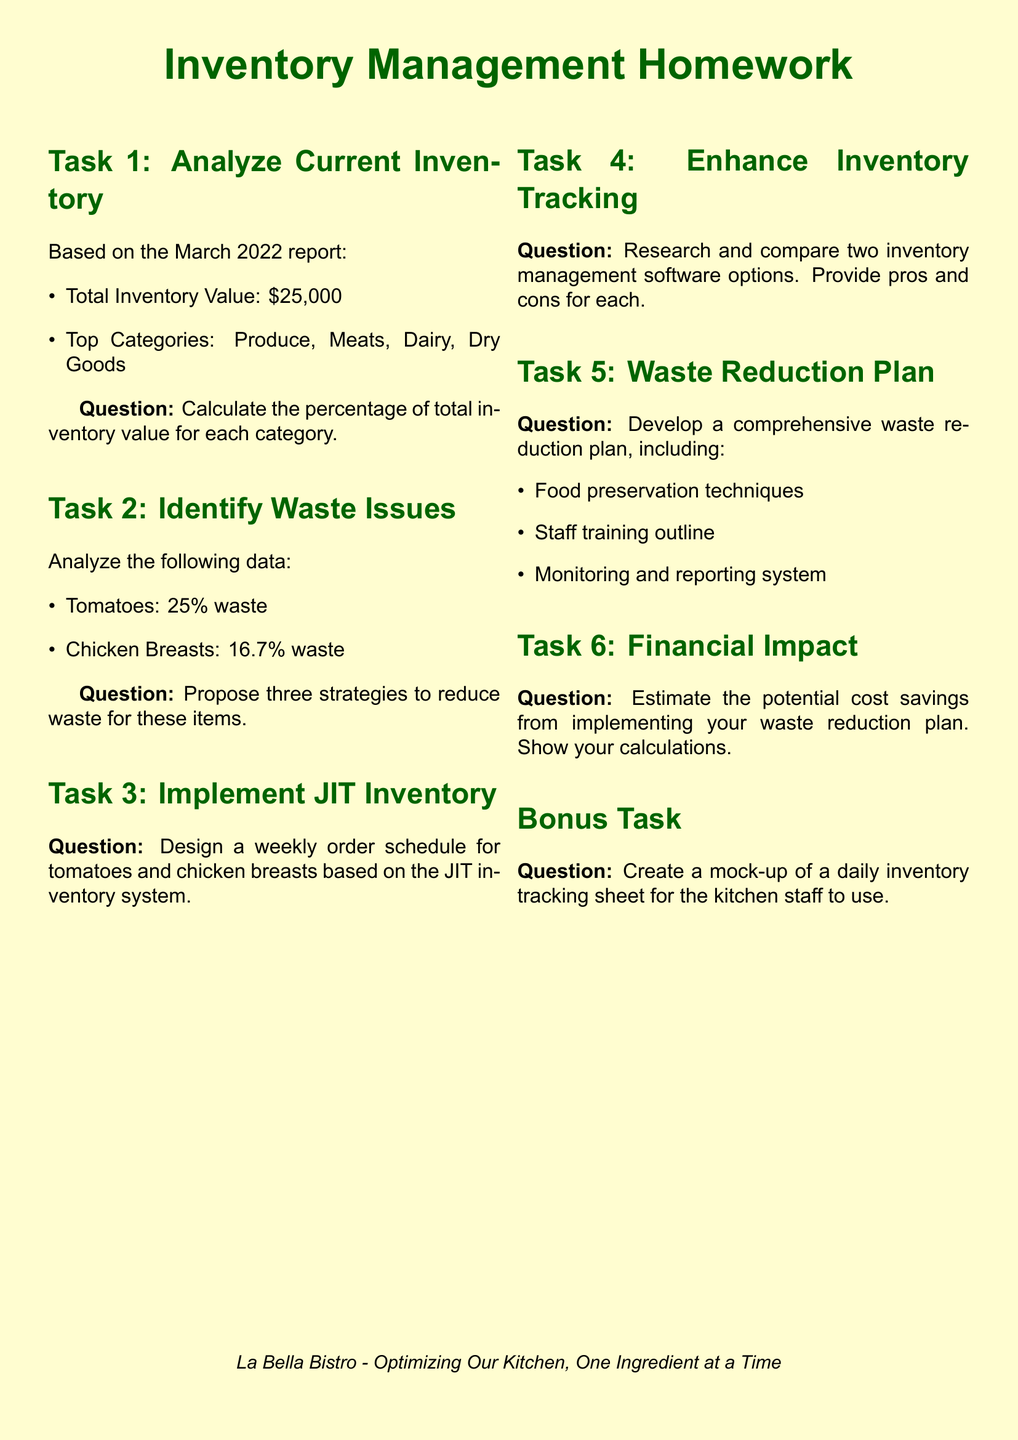What is the total inventory value? The total inventory value is explicitly stated in the document.
Answer: $25,000 What are the top inventory categories? The document lists the top categories under the analysis section.
Answer: Produce, Meats, Dairy, Dry Goods What percentage of waste is associated with tomatoes? The document provides the waste percentage for tomatoes in the waste analysis section.
Answer: 25% How many strategies need to be proposed to reduce waste? The question mentions proposing a certain number of strategies as part of the waste analysis task.
Answer: Three What is the task that involves a weekly order schedule? The specific task that relates to weekly ordering is indicated in the document.
Answer: Task 3 What elements are required in the waste reduction plan? The document lists the required elements under the waste reduction plan section.
Answer: Food preservation techniques, Staff training outline, Monitoring and reporting system What is the estimated focus of Task 6? The document outlines what Task 6 requires, which relates to financial implications.
Answer: Cost savings from waste reduction plan What type of inventory tracking document is suggested in the bonus task? The bonus task mentions creating a specific type of document for inventory management.
Answer: Daily inventory tracking sheet 